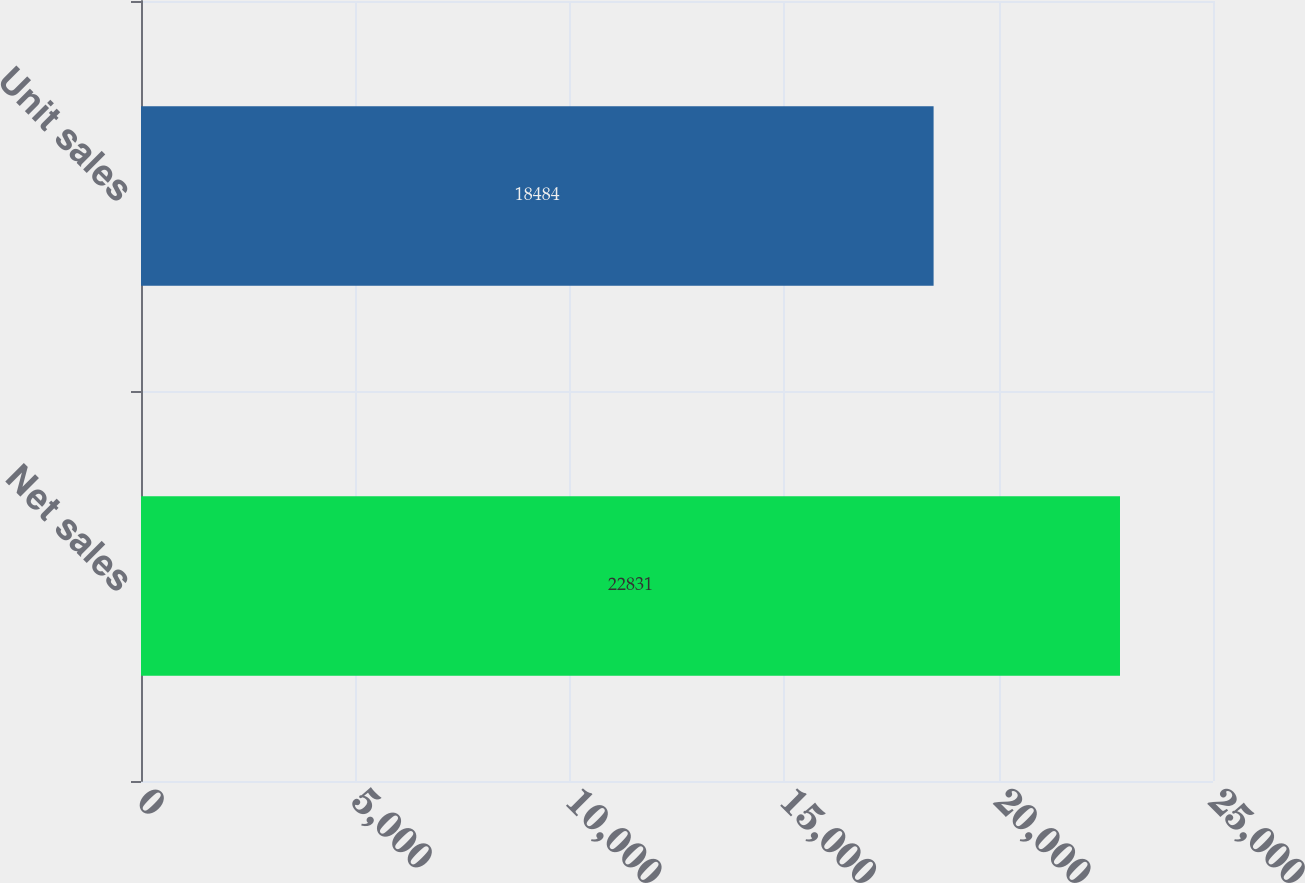<chart> <loc_0><loc_0><loc_500><loc_500><bar_chart><fcel>Net sales<fcel>Unit sales<nl><fcel>22831<fcel>18484<nl></chart> 